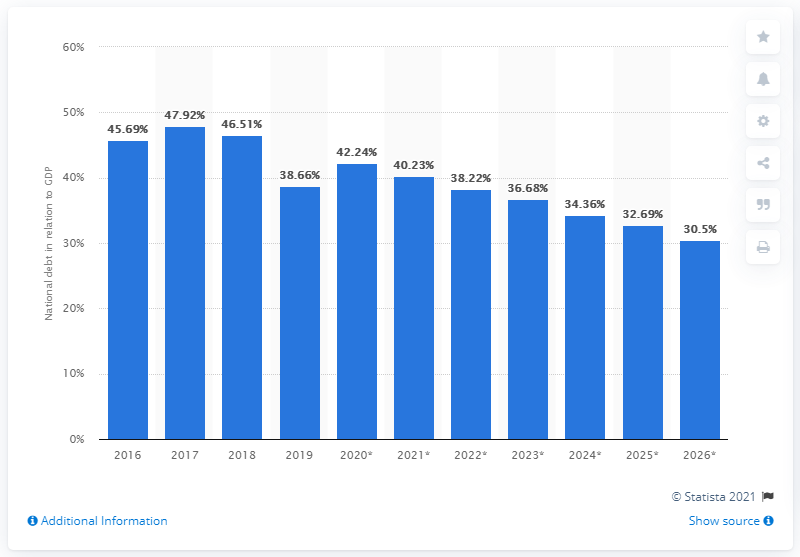Identify some key points in this picture. In 2019, the national debt of Djibouti accounted for 38.66% of the country's Gross Domestic Product (GDP). 